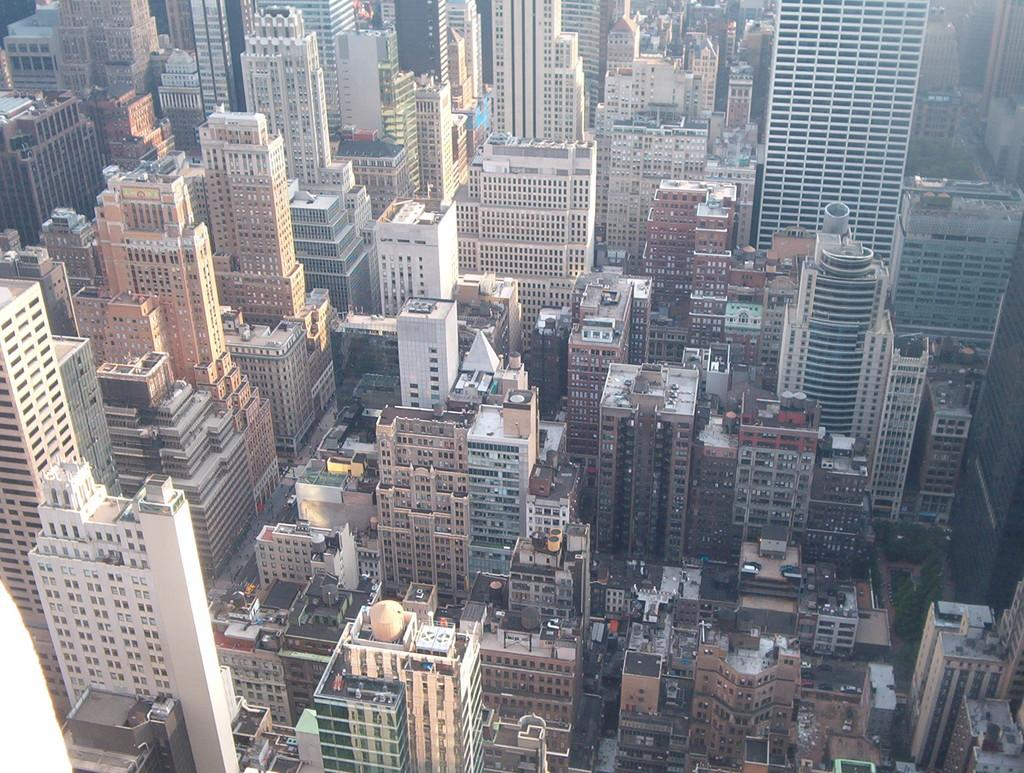What perspective is the image taken from? The image is taken from a top view. What types of structures can be seen in the image? There are many buildings in the image, including skyscrapers. How many cars can be seen in the image? There are no cars visible in the image, as it is taken from a top view and focuses on buildings. What type of frog can be seen on top of the skyscraper in the image? There is no frog present in the image; it only features buildings and skyscrapers. 